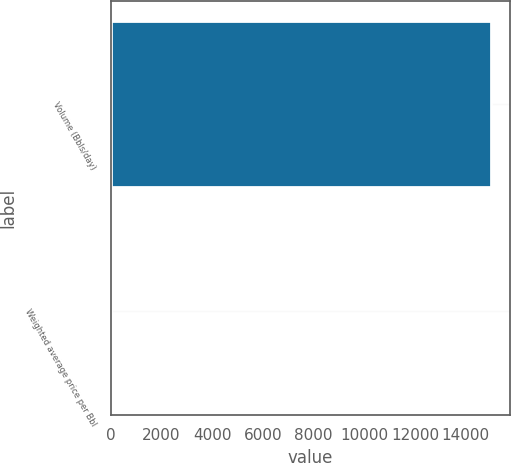Convert chart to OTSL. <chart><loc_0><loc_0><loc_500><loc_500><bar_chart><fcel>Volume (Bbls/day)<fcel>Weighted average price per Bbl<nl><fcel>15000<fcel>0.94<nl></chart> 